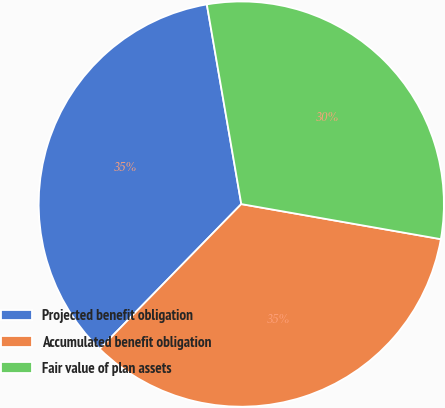<chart> <loc_0><loc_0><loc_500><loc_500><pie_chart><fcel>Projected benefit obligation<fcel>Accumulated benefit obligation<fcel>Fair value of plan assets<nl><fcel>34.96%<fcel>34.55%<fcel>30.49%<nl></chart> 